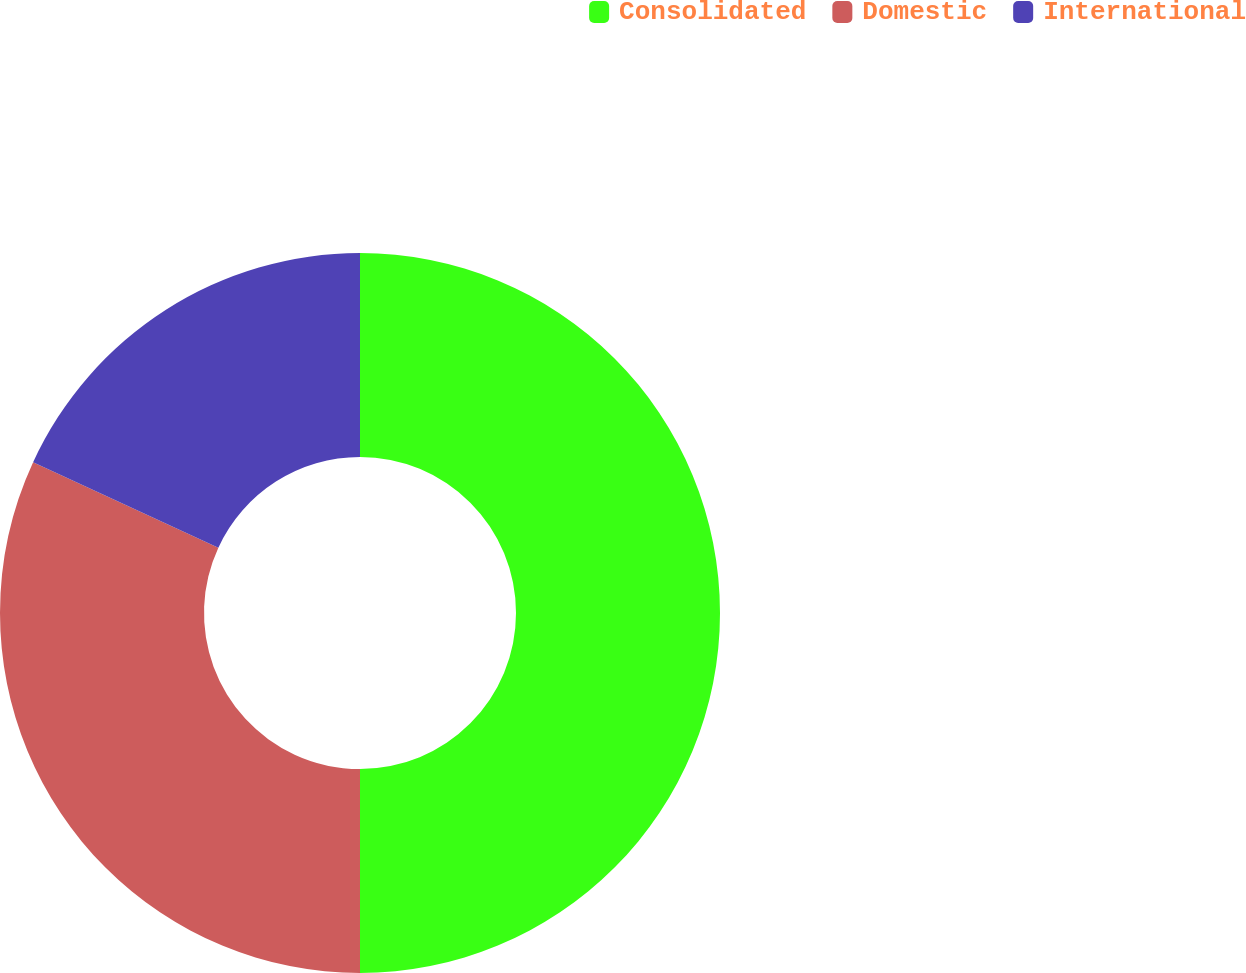<chart> <loc_0><loc_0><loc_500><loc_500><pie_chart><fcel>Consolidated<fcel>Domestic<fcel>International<nl><fcel>50.0%<fcel>31.88%<fcel>18.12%<nl></chart> 